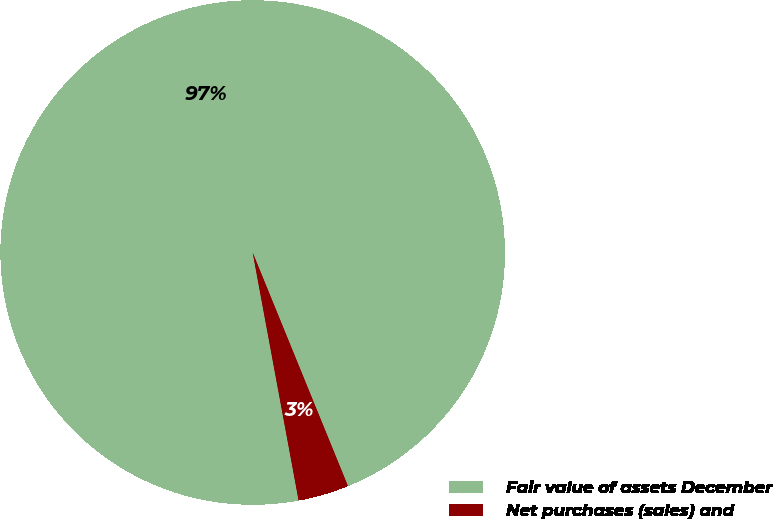<chart> <loc_0><loc_0><loc_500><loc_500><pie_chart><fcel>Fair value of assets December<fcel>Net purchases (sales) and<nl><fcel>96.75%<fcel>3.25%<nl></chart> 